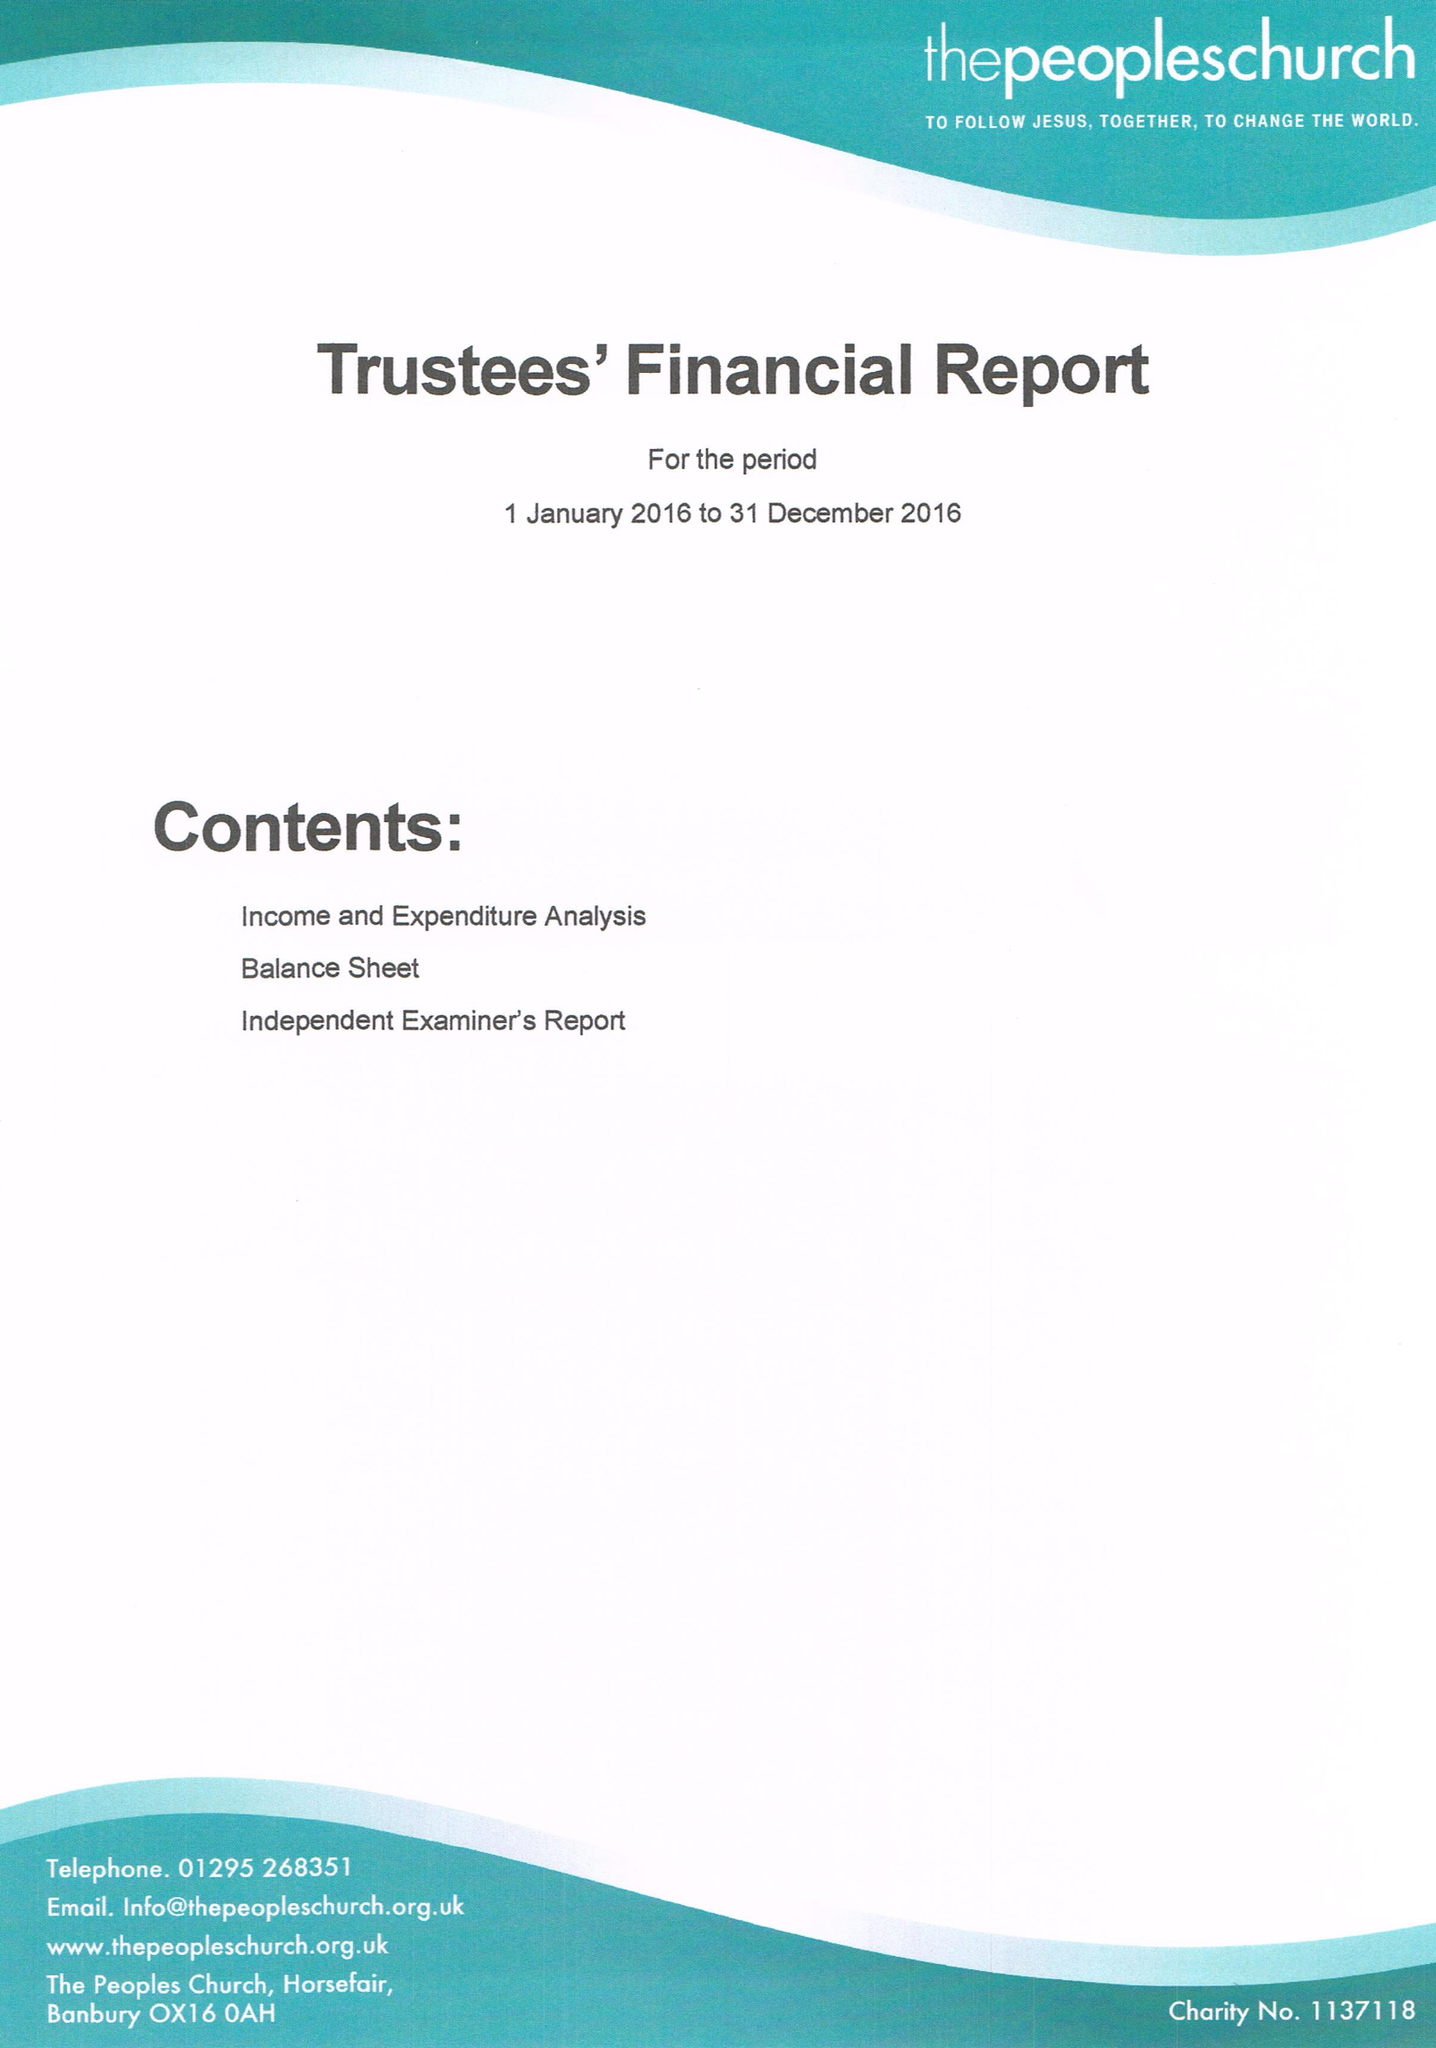What is the value for the charity_number?
Answer the question using a single word or phrase. 1137118 